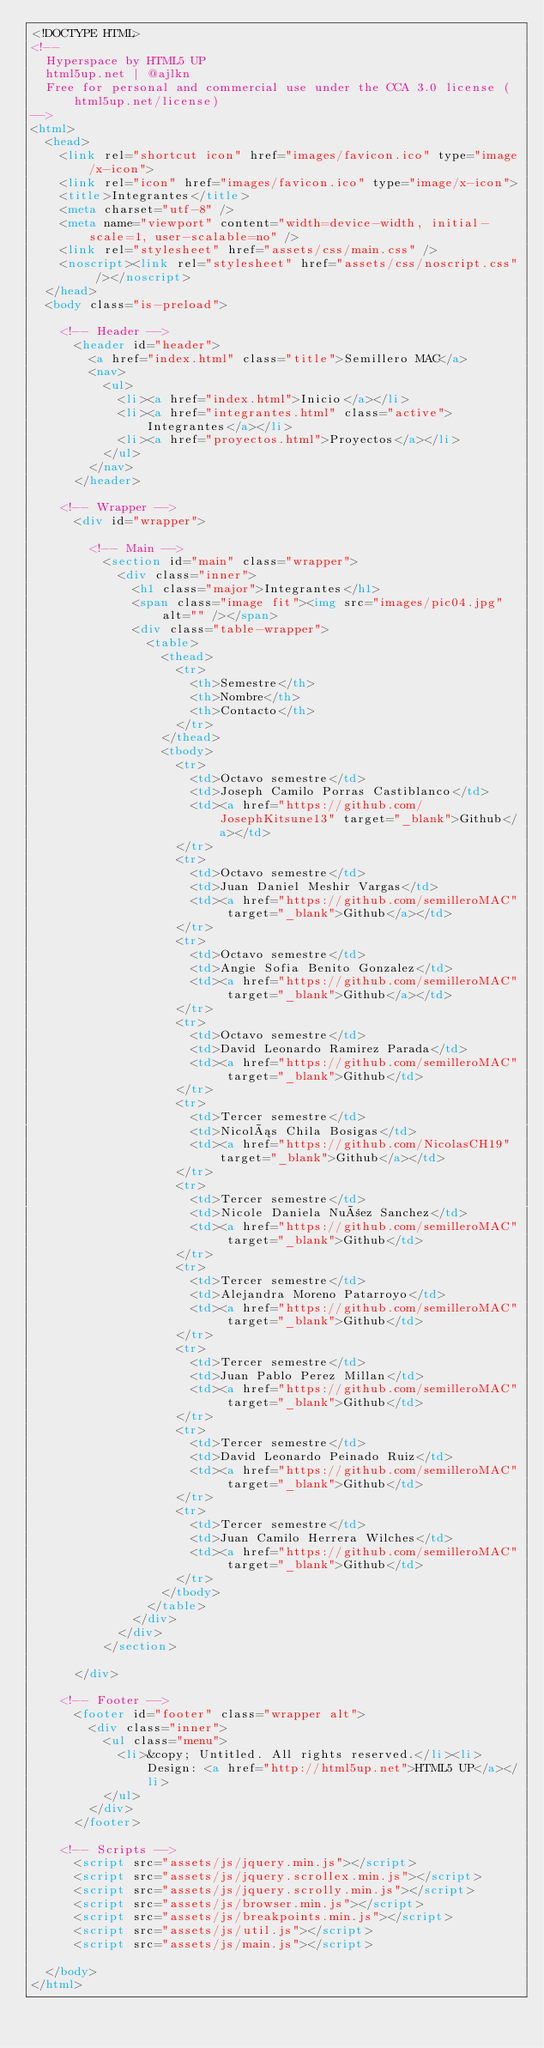<code> <loc_0><loc_0><loc_500><loc_500><_HTML_><!DOCTYPE HTML>
<!--
	Hyperspace by HTML5 UP
	html5up.net | @ajlkn
	Free for personal and commercial use under the CCA 3.0 license (html5up.net/license)
-->
<html>
	<head>
		<link rel="shortcut icon" href="images/favicon.ico" type="image/x-icon">
		<link rel="icon" href="images/favicon.ico" type="image/x-icon">
		<title>Integrantes</title>
		<meta charset="utf-8" />
		<meta name="viewport" content="width=device-width, initial-scale=1, user-scalable=no" />
		<link rel="stylesheet" href="assets/css/main.css" />
		<noscript><link rel="stylesheet" href="assets/css/noscript.css" /></noscript>
	</head>
	<body class="is-preload">

		<!-- Header -->
			<header id="header">
				<a href="index.html" class="title">Semillero MAC</a>
				<nav>
					<ul>
						<li><a href="index.html">Inicio</a></li>
						<li><a href="integrantes.html" class="active">Integrantes</a></li>
						<li><a href="proyectos.html">Proyectos</a></li>
					</ul>
				</nav>
			</header>

		<!-- Wrapper -->
			<div id="wrapper">

				<!-- Main -->
					<section id="main" class="wrapper">
						<div class="inner">
							<h1 class="major">Integrantes</h1>
							<span class="image fit"><img src="images/pic04.jpg" alt="" /></span>
							<div class="table-wrapper">
								<table>
									<thead>
										<tr>
											<th>Semestre</th>
											<th>Nombre</th>
											<th>Contacto</th>
										</tr>
									</thead>
									<tbody>
										<tr>
											<td>Octavo semestre</td>
											<td>Joseph Camilo Porras Castiblanco</td>
											<td><a href="https://github.com/JosephKitsune13" target="_blank">Github</a></td>
										</tr>
										<tr>
											<td>Octavo semestre</td>
											<td>Juan Daniel Meshir Vargas</td>
											<td><a href="https://github.com/semilleroMAC" target="_blank">Github</a></td>
										</tr>
										<tr>
											<td>Octavo semestre</td>
											<td>Angie Sofia Benito Gonzalez</td>
											<td><a href="https://github.com/semilleroMAC" target="_blank">Github</a></td>
										</tr>
										<tr>
											<td>Octavo semestre</td>
											<td>David Leonardo Ramirez Parada</td>
											<td><a href="https://github.com/semilleroMAC" target="_blank">Github</td>
										</tr>
										<tr>
											<td>Tercer semestre</td>
											<td>Nicolás Chila Bosigas</td>
											<td><a href="https://github.com/NicolasCH19" target="_blank">Github</a></td>
										</tr>
										<tr>
											<td>Tercer semestre</td>
											<td>Nicole Daniela Nuñez Sanchez</td>
											<td><a href="https://github.com/semilleroMAC" target="_blank">Github</td>
										</tr>
										<tr>
											<td>Tercer semestre</td>
											<td>Alejandra Moreno Patarroyo</td>
											<td><a href="https://github.com/semilleroMAC" target="_blank">Github</td>
										</tr>
										<tr>
											<td>Tercer semestre</td>
											<td>Juan Pablo Perez Millan</td>
											<td><a href="https://github.com/semilleroMAC" target="_blank">Github</td>
										</tr>
										<tr>
											<td>Tercer semestre</td>
											<td>David Leonardo Peinado Ruiz</td>
											<td><a href="https://github.com/semilleroMAC" target="_blank">Github</td>
										</tr>
										<tr>
											<td>Tercer semestre</td>
											<td>Juan Camilo Herrera Wilches</td>
											<td><a href="https://github.com/semilleroMAC" target="_blank">Github</td>
										</tr>
									</tbody>
								</table>
							</div>
						</div>
					</section>

			</div>

		<!-- Footer -->
			<footer id="footer" class="wrapper alt">
				<div class="inner">
					<ul class="menu">
						<li>&copy; Untitled. All rights reserved.</li><li>Design: <a href="http://html5up.net">HTML5 UP</a></li>
					</ul>
				</div>
			</footer>

		<!-- Scripts -->
			<script src="assets/js/jquery.min.js"></script>
			<script src="assets/js/jquery.scrollex.min.js"></script>
			<script src="assets/js/jquery.scrolly.min.js"></script>
			<script src="assets/js/browser.min.js"></script>
			<script src="assets/js/breakpoints.min.js"></script>
			<script src="assets/js/util.js"></script>
			<script src="assets/js/main.js"></script>

	</body>
</html>
</code> 